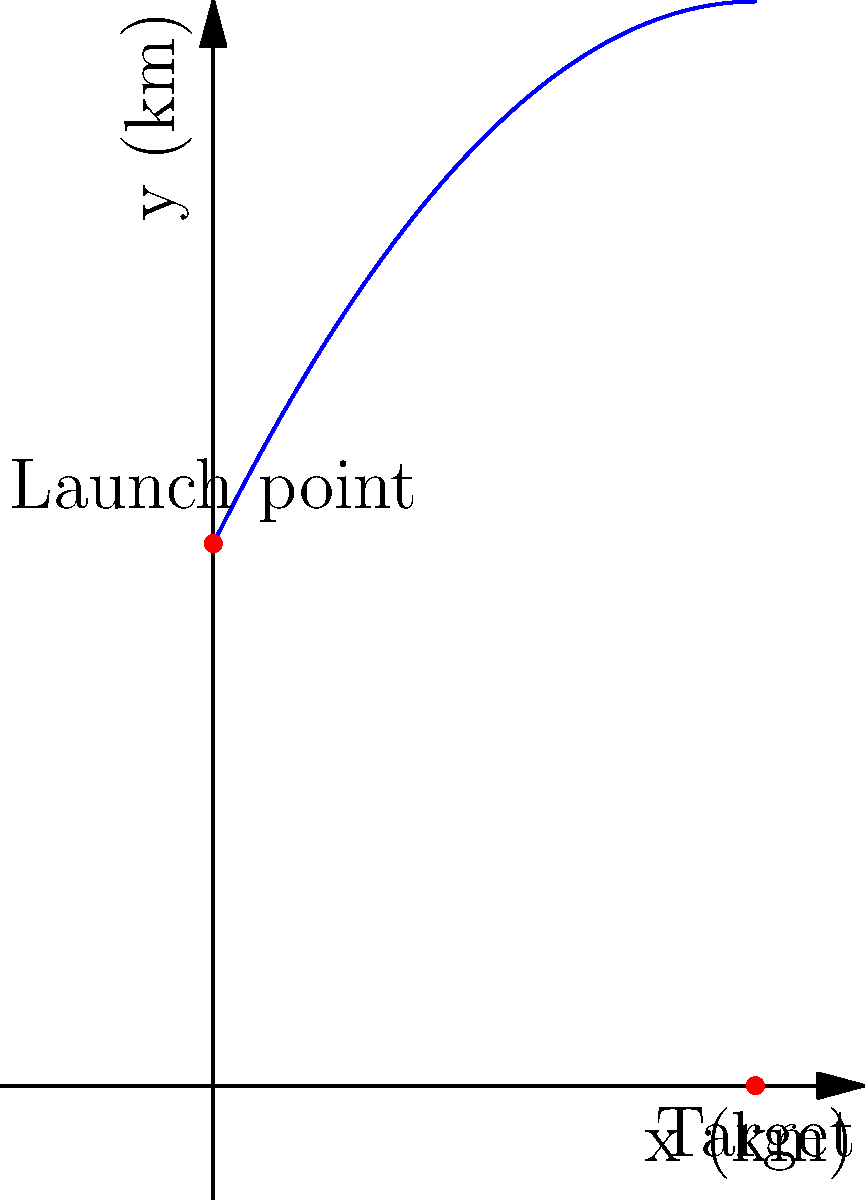A drone is launched from a point (0, 10) km and follows a parabolic path described by the equation $y = -0.1x^2 + 2x + 10$, where x and y are measured in kilometers. The drone's target is located on the ground at (10, 0) km. Calculate the maximum height reached by the drone during its flight. To find the maximum height of the drone's flight path, we need to follow these steps:

1) The parabola's equation is $y = -0.1x^2 + 2x + 10$

2) The maximum height occurs at the vertex of the parabola. For a parabola in the form $y = ax^2 + bx + c$, the x-coordinate of the vertex is given by $x = -\frac{b}{2a}$

3) In our equation, $a = -0.1$ and $b = 2$. Let's calculate the x-coordinate of the vertex:

   $x = -\frac{2}{2(-0.1)} = -\frac{2}{-0.2} = 10$

4) To find the y-coordinate (the maximum height), we substitute this x-value back into the original equation:

   $y = -0.1(10)^2 + 2(10) + 10$
   $= -0.1(100) + 20 + 10$
   $= -10 + 20 + 10$
   $= 20$

5) Therefore, the maximum height is reached at the point (10, 20) km.
Answer: 20 km 